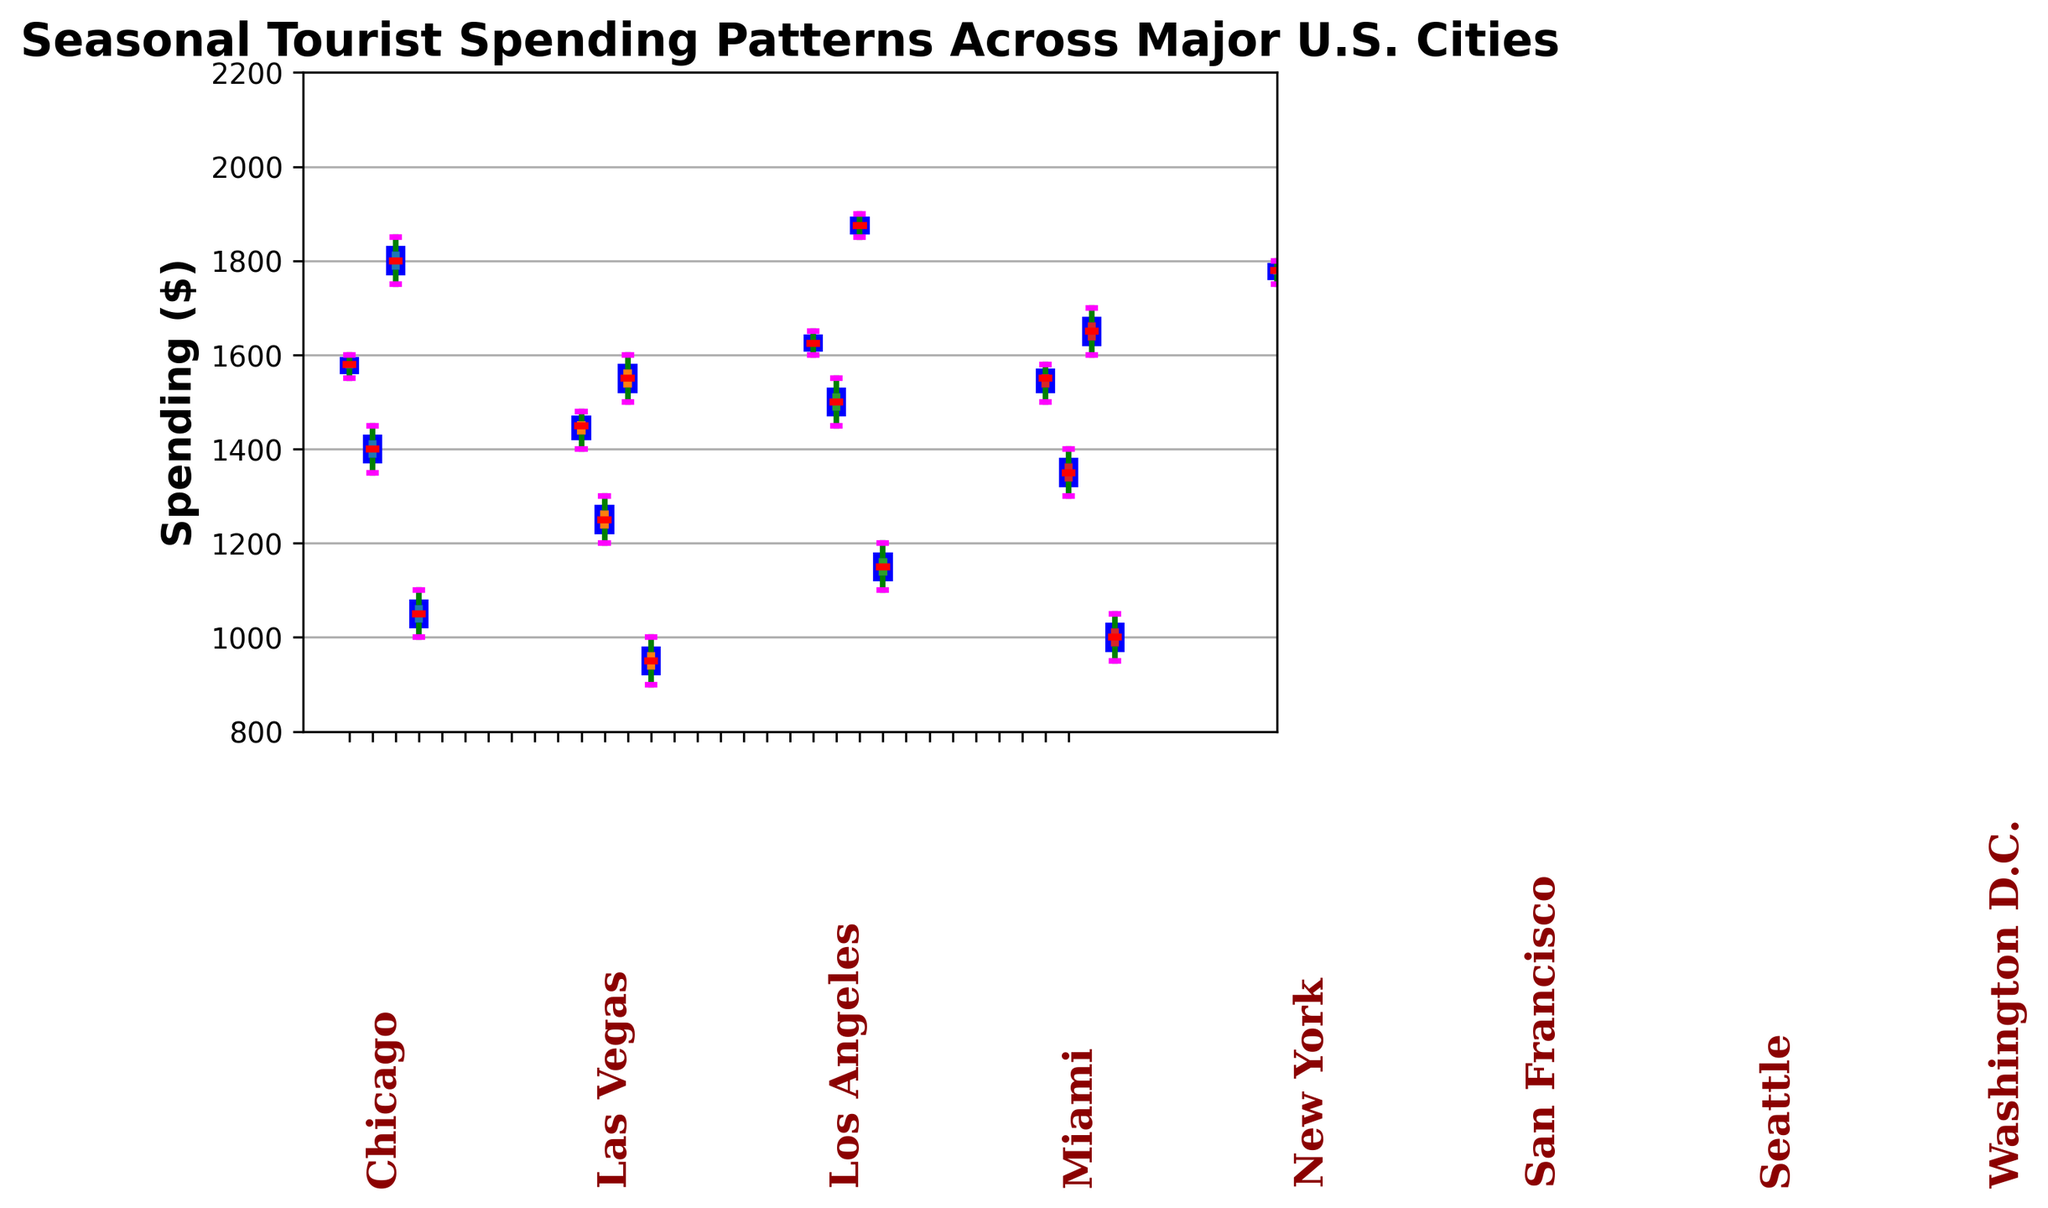Which city has the highest median tourist spending during Summer? To determine this, look at the median lines (colored red) within the Summer box plots for each city and identify the highest one.
Answer: New York In which season does Washington D.C. have the widest range of tourist spending? Review the difference between the top and bottom whiskers for Washington D.C. across all seasons. The widest range appears in Summer.
Answer: Summer What is the average median spending across all cities during the Fall? Calculate the median spending for Fall for each city (middle line in each box plot for Fall) and average them together. Steps: (1750 + 1650 + 1580 + 1550 + 1650 + 1450 + 1525 + 1750) / 8.
Answer: 1613.75 Which season shows the least variation in spending for Las Vegas? Identify the season for Las Vegas with the smallest interquartile range (width of the box). This is clearly seen for Winter.
Answer: Winter Compare the median spending between New York in Winter and Los Angeles in Summer. Which is higher? Compare the median lines (red lines) of New York in Winter and Los Angeles in Summer. The median for Los Angeles in Summer appears higher.
Answer: Los Angeles in Summer Is the interquartile range for Summer spending wider in Chicago or Miami? Examine the size of the boxes representing the interquartile ranges for Summer in both cities. The interquartile range is wider for Chicago.
Answer: Chicago How does the median tourist spending in Spring for San Francisco compare to that of Seattle in Winter? Compare the median lines (red lines) for San Francisco in Spring and Seattle in Winter. San Francisco in Spring has a higher median.
Answer: San Francisco in Spring Which city exhibits the most consistent spending patterns across all seasons (least fluctuation)? Identify the city with the smallest overall spread across all box plots in different seasons. Las Vegas shows the most consistent spending patterns.
Answer: Las Vegas How much higher is the median spending in New York during Summer compared to Fall? Determine the median spending for New York in Summer and Fall, then subtract Fall's median from Summer's median. (2050 - 1780 = 270).
Answer: 270 